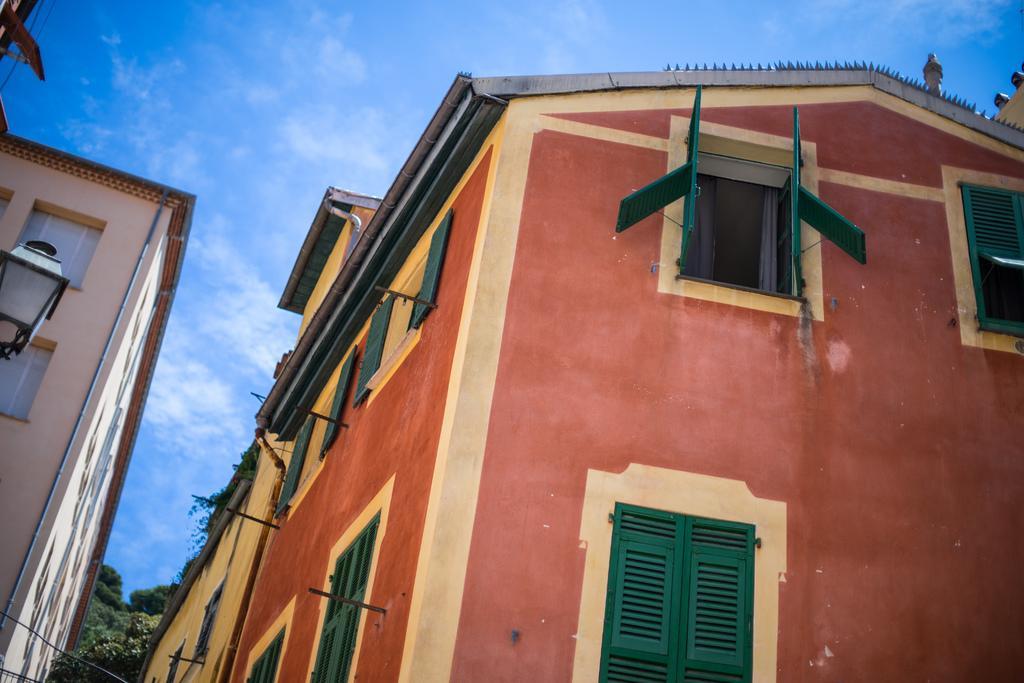Please provide a concise description of this image. In the foreground of the picture there are buildings, to the buildings there are windows. On the left there is a street light. In the center of the background we can see trees. Sky is sunny. 